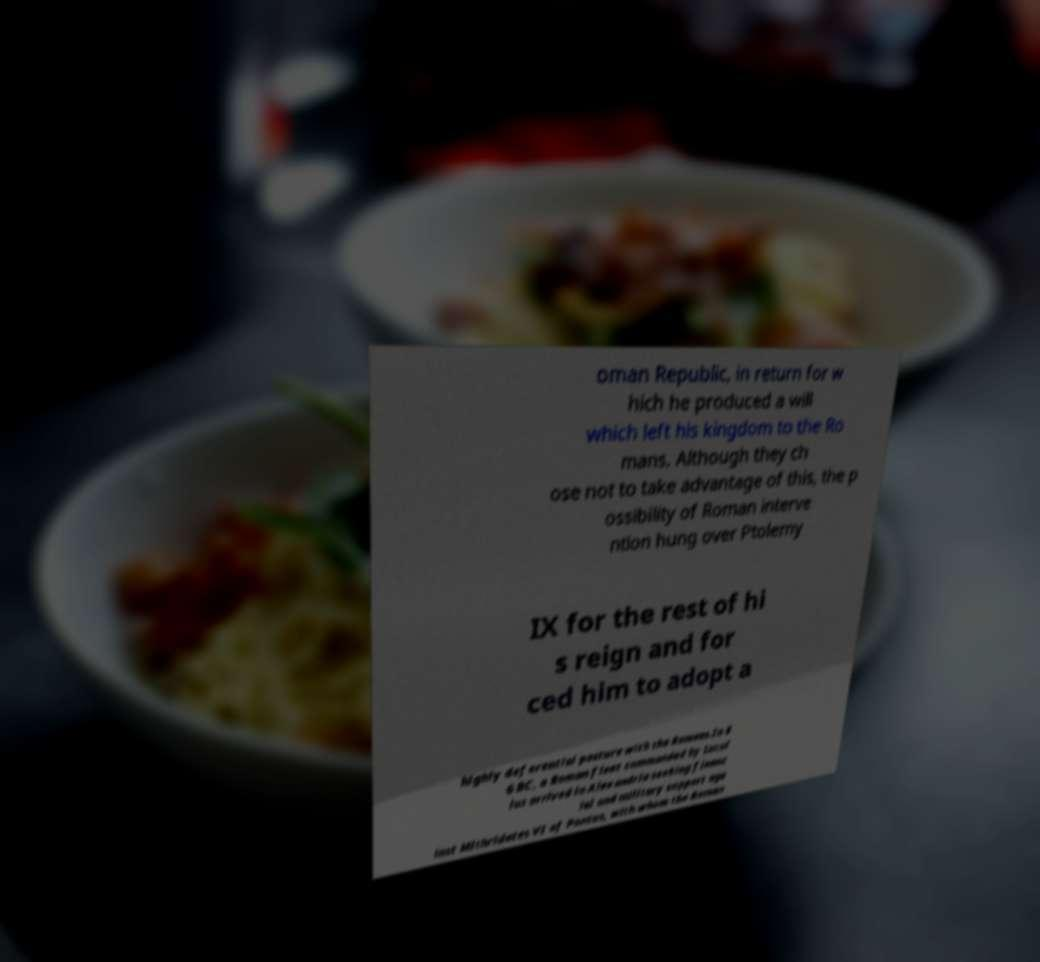I need the written content from this picture converted into text. Can you do that? oman Republic, in return for w hich he produced a will which left his kingdom to the Ro mans. Although they ch ose not to take advantage of this, the p ossibility of Roman interve ntion hung over Ptolemy IX for the rest of hi s reign and for ced him to adopt a highly deferential posture with the Romans.In 8 6 BC, a Roman fleet commanded by Lucul lus arrived in Alexandria seeking financ ial and military support aga inst Mithridates VI of Pontus, with whom the Roman 